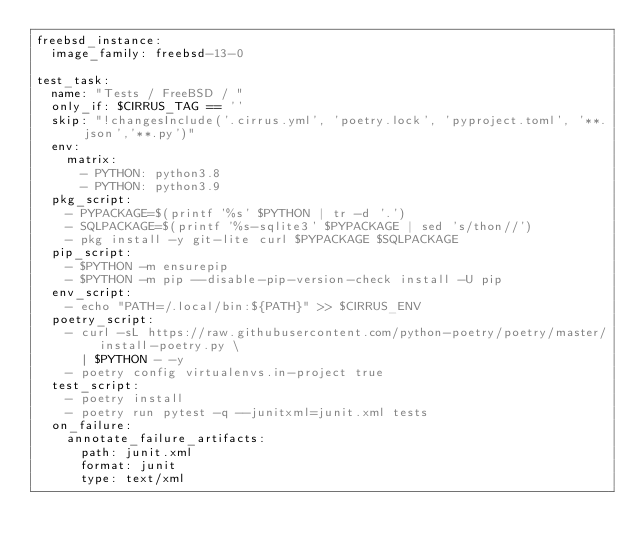<code> <loc_0><loc_0><loc_500><loc_500><_YAML_>freebsd_instance:
  image_family: freebsd-13-0

test_task:
  name: "Tests / FreeBSD / "
  only_if: $CIRRUS_TAG == ''
  skip: "!changesInclude('.cirrus.yml', 'poetry.lock', 'pyproject.toml', '**.json','**.py')"
  env:
    matrix:
      - PYTHON: python3.8
      - PYTHON: python3.9
  pkg_script:
    - PYPACKAGE=$(printf '%s' $PYTHON | tr -d '.')
    - SQLPACKAGE=$(printf '%s-sqlite3' $PYPACKAGE | sed 's/thon//')
    - pkg install -y git-lite curl $PYPACKAGE $SQLPACKAGE
  pip_script:
    - $PYTHON -m ensurepip
    - $PYTHON -m pip --disable-pip-version-check install -U pip
  env_script:
    - echo "PATH=/.local/bin:${PATH}" >> $CIRRUS_ENV
  poetry_script:
    - curl -sL https://raw.githubusercontent.com/python-poetry/poetry/master/install-poetry.py \
      | $PYTHON - -y
    - poetry config virtualenvs.in-project true
  test_script:
    - poetry install
    - poetry run pytest -q --junitxml=junit.xml tests
  on_failure:
    annotate_failure_artifacts:
      path: junit.xml
      format: junit
      type: text/xml
</code> 